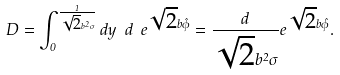Convert formula to latex. <formula><loc_0><loc_0><loc_500><loc_500>D = \int _ { 0 } ^ { \frac { 1 } { \sqrt { 2 } b ^ { 2 } \sigma } } d y \ d \ e ^ { \sqrt { 2 } b \hat { \phi } } = \frac { d } { \sqrt { 2 } b ^ { 2 } \sigma } e ^ { \sqrt { 2 } b \hat { \phi } } .</formula> 